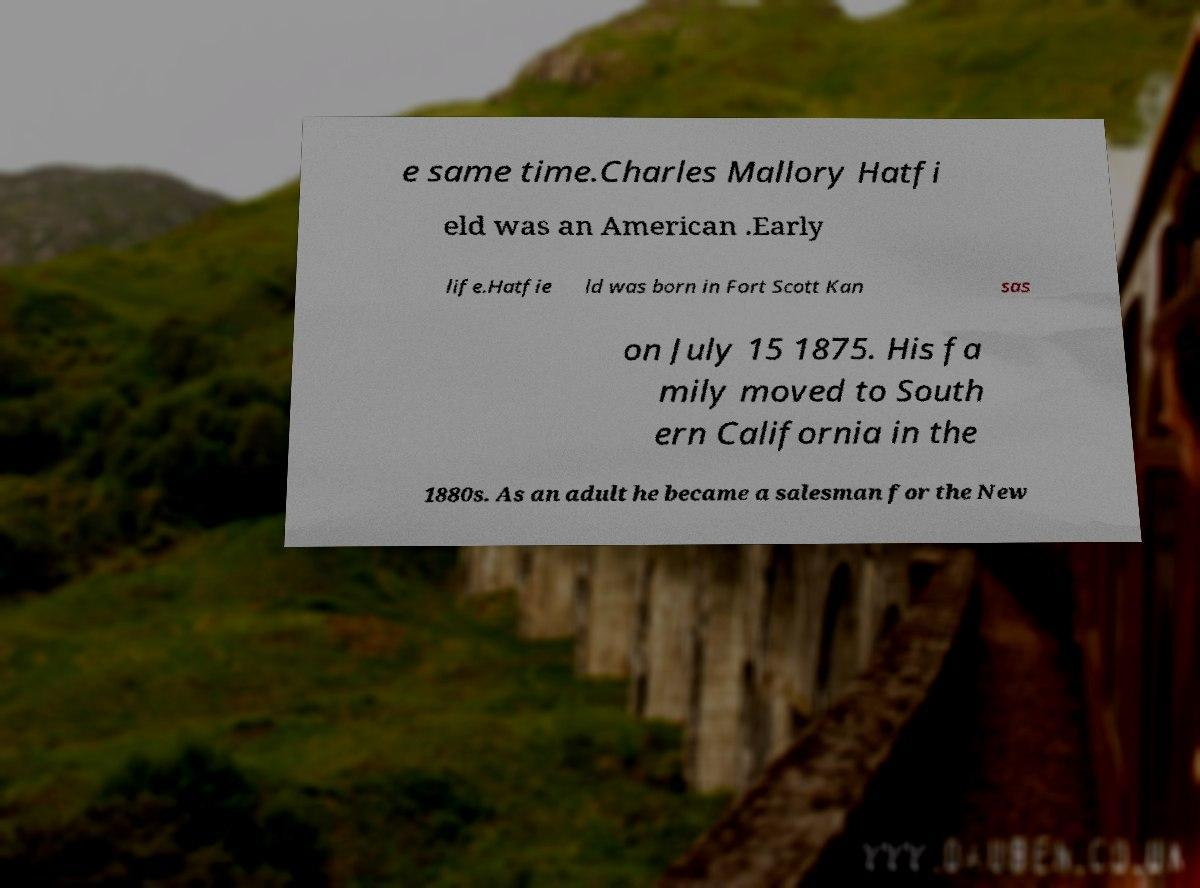Can you accurately transcribe the text from the provided image for me? e same time.Charles Mallory Hatfi eld was an American .Early life.Hatfie ld was born in Fort Scott Kan sas on July 15 1875. His fa mily moved to South ern California in the 1880s. As an adult he became a salesman for the New 